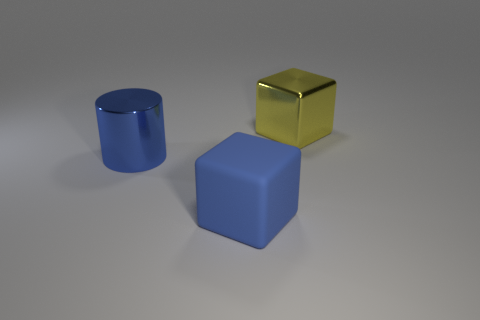Add 2 large blue matte blocks. How many objects exist? 5 Subtract all blocks. How many objects are left? 1 Add 1 large matte objects. How many large matte objects exist? 2 Subtract 0 green balls. How many objects are left? 3 Subtract all big rubber cubes. Subtract all big blue matte things. How many objects are left? 1 Add 1 large yellow metallic cubes. How many large yellow metallic cubes are left? 2 